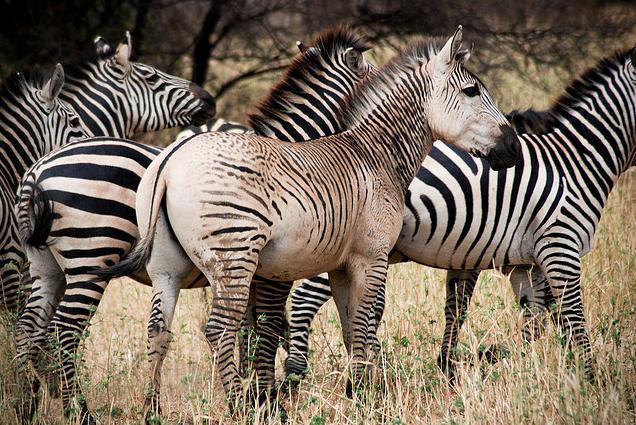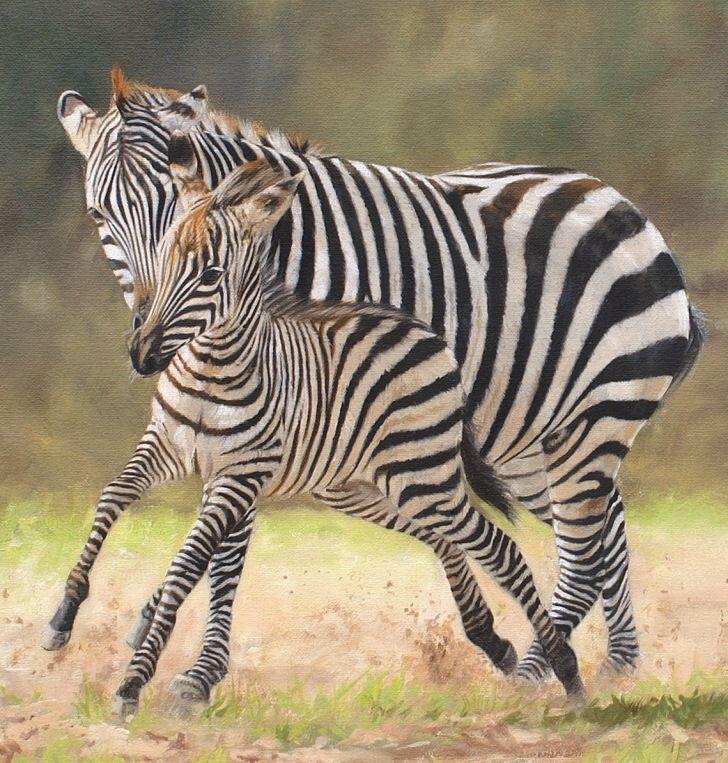The first image is the image on the left, the second image is the image on the right. Considering the images on both sides, is "There is a single zebra in at least one of the images." valid? Answer yes or no. No. 